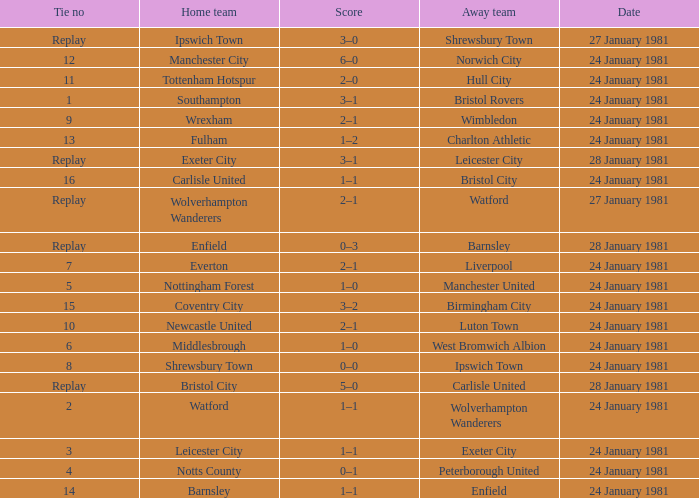What is the score when the tie is 8? 0–0. 